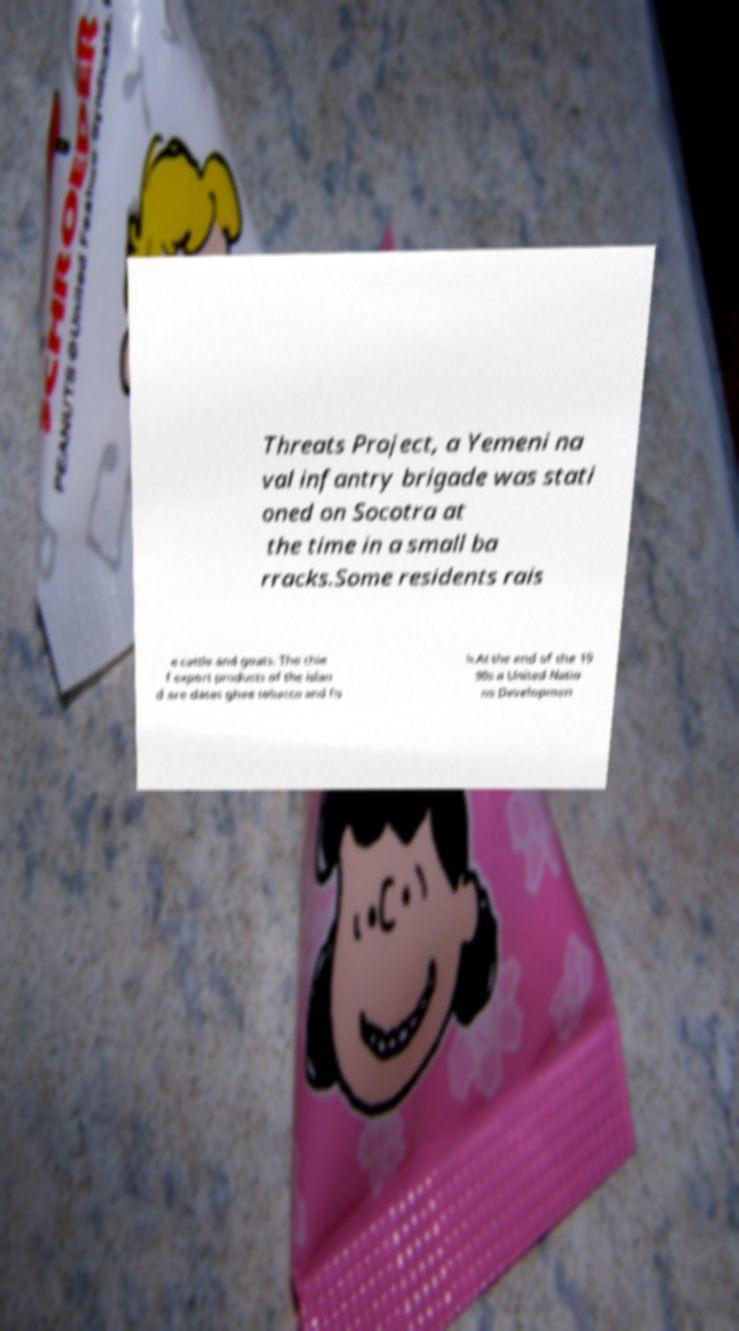What messages or text are displayed in this image? I need them in a readable, typed format. Threats Project, a Yemeni na val infantry brigade was stati oned on Socotra at the time in a small ba rracks.Some residents rais e cattle and goats. The chie f export products of the islan d are dates ghee tobacco and fis h.At the end of the 19 90s a United Natio ns Developmen 